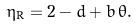<formula> <loc_0><loc_0><loc_500><loc_500>\eta _ { \text {R} } = 2 - d + b \, \theta .</formula> 